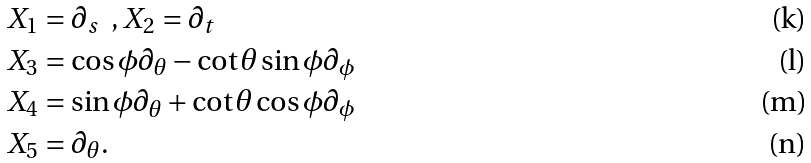Convert formula to latex. <formula><loc_0><loc_0><loc_500><loc_500>X _ { 1 } & = \partial _ { s } \ \ , X _ { 2 } = \partial _ { t } \\ X _ { 3 } & = \cos \phi \partial _ { \theta } - \cot \theta \sin \phi \partial _ { \phi } \\ X _ { 4 } & = \sin \phi \partial _ { \theta } + \cot \theta \cos \phi \partial _ { \phi } \\ X _ { 5 } & = \partial _ { \theta } .</formula> 